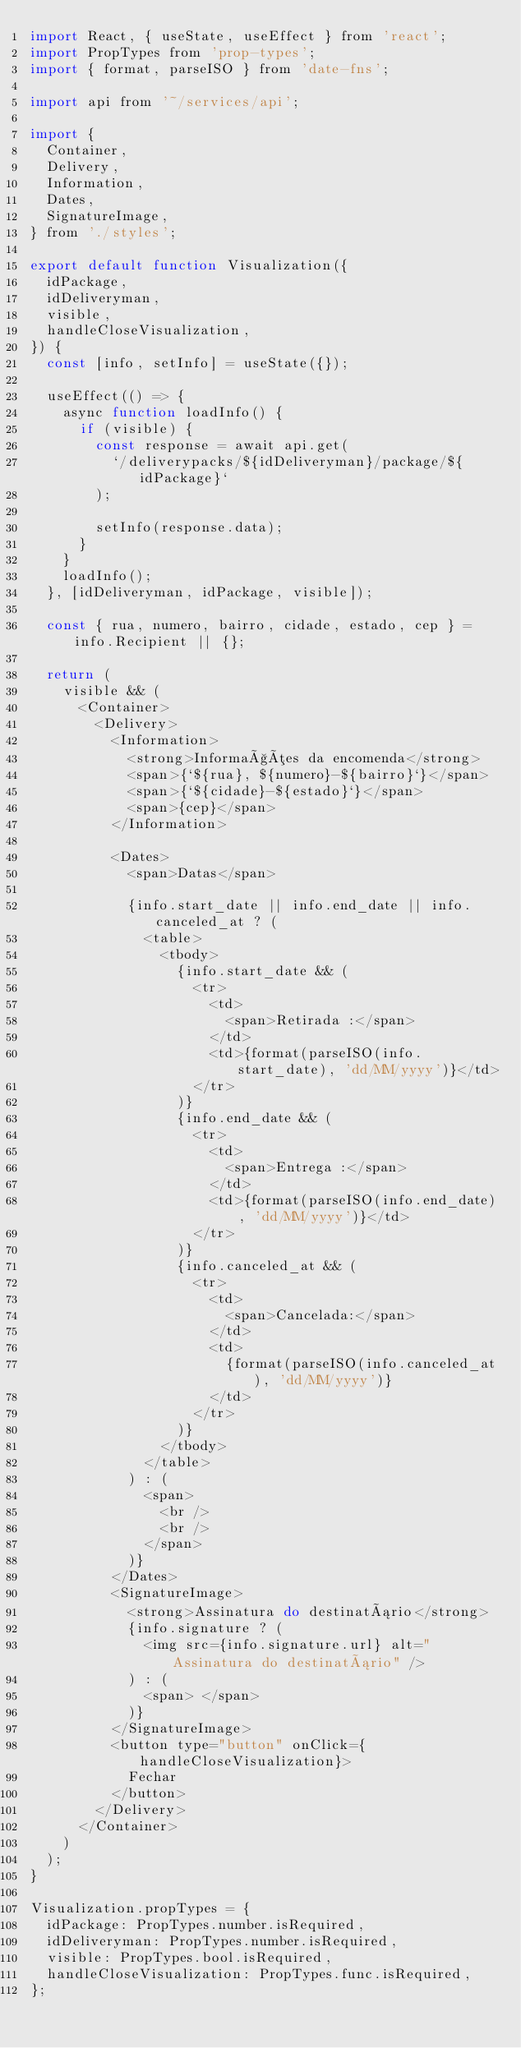Convert code to text. <code><loc_0><loc_0><loc_500><loc_500><_JavaScript_>import React, { useState, useEffect } from 'react';
import PropTypes from 'prop-types';
import { format, parseISO } from 'date-fns';

import api from '~/services/api';

import {
  Container,
  Delivery,
  Information,
  Dates,
  SignatureImage,
} from './styles';

export default function Visualization({
  idPackage,
  idDeliveryman,
  visible,
  handleCloseVisualization,
}) {
  const [info, setInfo] = useState({});

  useEffect(() => {
    async function loadInfo() {
      if (visible) {
        const response = await api.get(
          `/deliverypacks/${idDeliveryman}/package/${idPackage}`
        );

        setInfo(response.data);
      }
    }
    loadInfo();
  }, [idDeliveryman, idPackage, visible]);

  const { rua, numero, bairro, cidade, estado, cep } = info.Recipient || {};

  return (
    visible && (
      <Container>
        <Delivery>
          <Information>
            <strong>Informações da encomenda</strong>
            <span>{`${rua}, ${numero}-${bairro}`}</span>
            <span>{`${cidade}-${estado}`}</span>
            <span>{cep}</span>
          </Information>

          <Dates>
            <span>Datas</span>

            {info.start_date || info.end_date || info.canceled_at ? (
              <table>
                <tbody>
                  {info.start_date && (
                    <tr>
                      <td>
                        <span>Retirada :</span>
                      </td>
                      <td>{format(parseISO(info.start_date), 'dd/MM/yyyy')}</td>
                    </tr>
                  )}
                  {info.end_date && (
                    <tr>
                      <td>
                        <span>Entrega :</span>
                      </td>
                      <td>{format(parseISO(info.end_date), 'dd/MM/yyyy')}</td>
                    </tr>
                  )}
                  {info.canceled_at && (
                    <tr>
                      <td>
                        <span>Cancelada:</span>
                      </td>
                      <td>
                        {format(parseISO(info.canceled_at), 'dd/MM/yyyy')}
                      </td>
                    </tr>
                  )}
                </tbody>
              </table>
            ) : (
              <span>
                <br />
                <br />
              </span>
            )}
          </Dates>
          <SignatureImage>
            <strong>Assinatura do destinatário</strong>
            {info.signature ? (
              <img src={info.signature.url} alt="Assinatura do destinatário" />
            ) : (
              <span> </span>
            )}
          </SignatureImage>
          <button type="button" onClick={handleCloseVisualization}>
            Fechar
          </button>
        </Delivery>
      </Container>
    )
  );
}

Visualization.propTypes = {
  idPackage: PropTypes.number.isRequired,
  idDeliveryman: PropTypes.number.isRequired,
  visible: PropTypes.bool.isRequired,
  handleCloseVisualization: PropTypes.func.isRequired,
};
</code> 